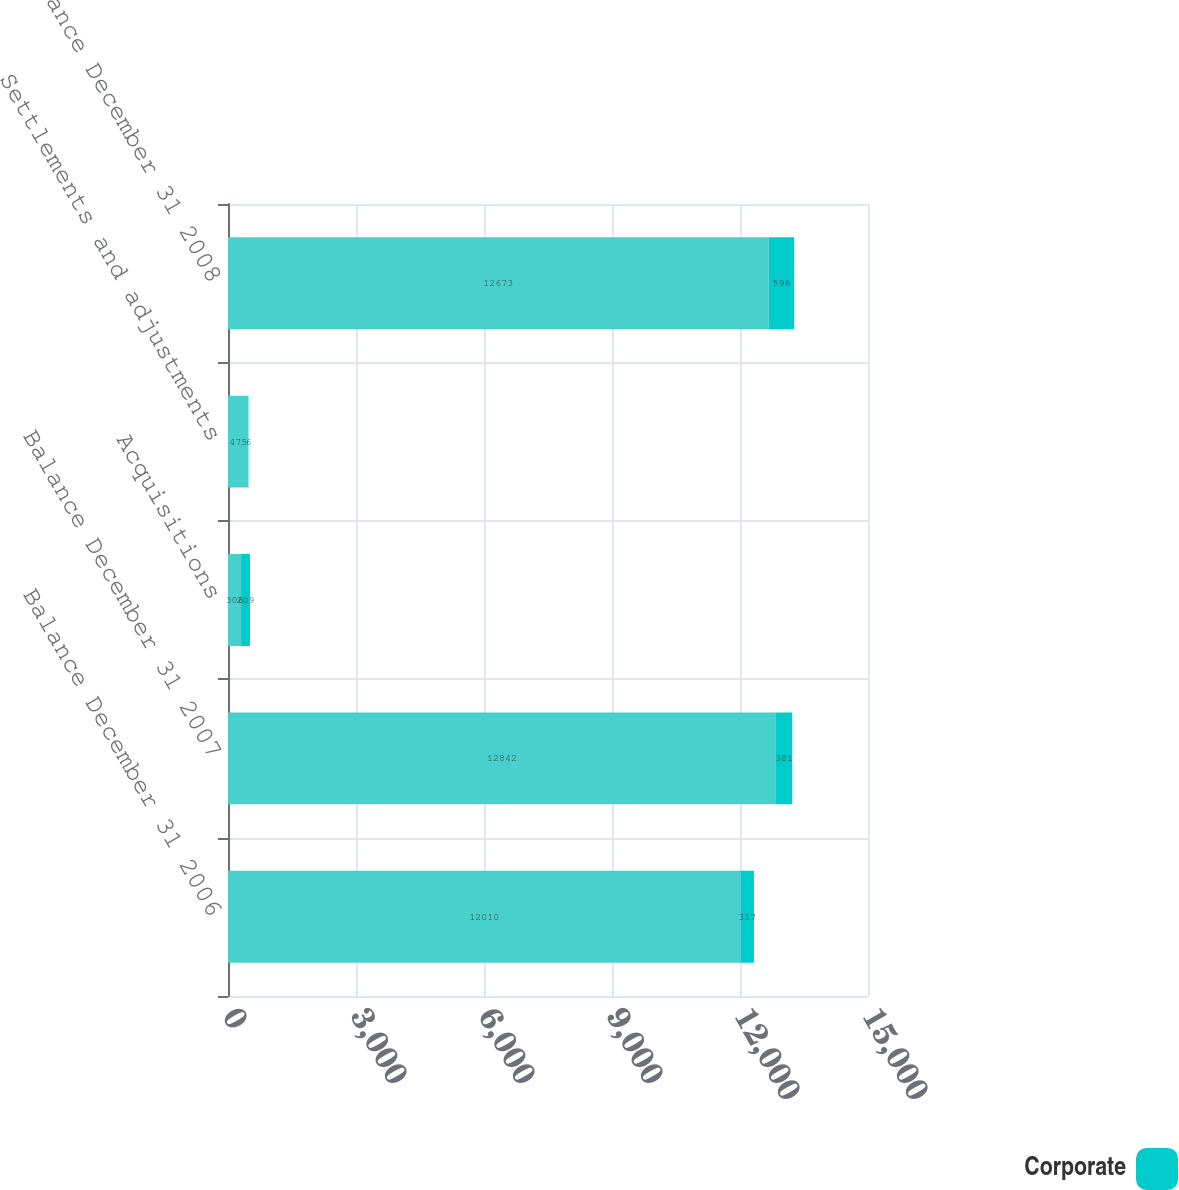<chart> <loc_0><loc_0><loc_500><loc_500><stacked_bar_chart><ecel><fcel>Balance December 31 2006<fcel>Balance December 31 2007<fcel>Acquisitions<fcel>Settlements and adjustments<fcel>Balance December 31 2008<nl><fcel>nan<fcel>12010<fcel>12842<fcel>306<fcel>475<fcel>12673<nl><fcel>Corporate<fcel>317<fcel>381<fcel>209<fcel>6<fcel>596<nl></chart> 